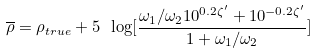<formula> <loc_0><loc_0><loc_500><loc_500>\overline { \rho } = \rho _ { t r u e } + 5 \ \log [ \frac { { \omega _ { 1 } } / { \omega _ { 2 } } 1 0 ^ { 0 . 2 \zeta ^ { \prime } } + 1 0 ^ { - 0 . 2 \zeta ^ { \prime } } } { 1 + { \omega _ { 1 } } / { \omega _ { 2 } } } ]</formula> 